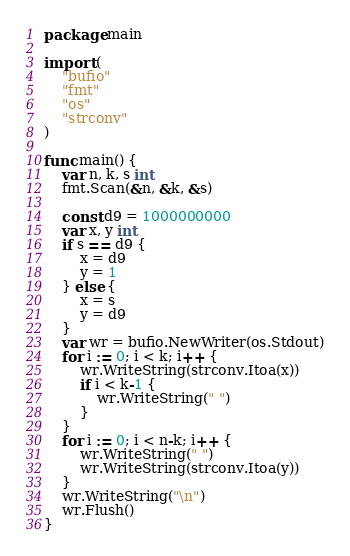Convert code to text. <code><loc_0><loc_0><loc_500><loc_500><_Go_>package main

import (
	"bufio"
	"fmt"
	"os"
	"strconv"
)

func main() {
	var n, k, s int
	fmt.Scan(&n, &k, &s)

	const d9 = 1000000000
	var x, y int
	if s == d9 {
		x = d9
		y = 1
	} else {
		x = s
		y = d9
	}
	var wr = bufio.NewWriter(os.Stdout)
	for i := 0; i < k; i++ {
		wr.WriteString(strconv.Itoa(x))
		if i < k-1 {
			wr.WriteString(" ")
		}
	}
	for i := 0; i < n-k; i++ {
		wr.WriteString(" ")
		wr.WriteString(strconv.Itoa(y))
	}
	wr.WriteString("\n")
	wr.Flush()
}
</code> 